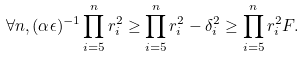Convert formula to latex. <formula><loc_0><loc_0><loc_500><loc_500>\forall n , ( \alpha \epsilon ) ^ { - 1 } \prod _ { i = 5 } ^ { n } r ^ { 2 } _ { i } \geq \prod _ { i = 5 } ^ { n } r ^ { 2 } _ { i } - \delta ^ { 2 } _ { i } \geq \prod _ { i = 5 } ^ { n } r ^ { 2 } _ { i } F .</formula> 